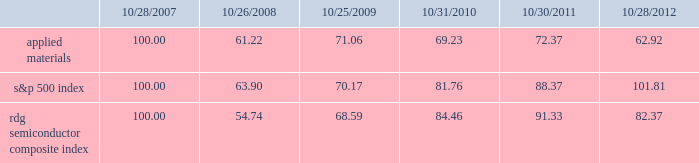Performance graph the performance graph below shows the five-year cumulative total stockholder return on applied common stock during the period from october 28 , 2007 through october 28 , 2012 .
This is compared with the cumulative total return of the standard & poor 2019s 500 stock index and the rdg semiconductor composite index over the same period .
The comparison assumes $ 100 was invested on october 28 , 2007 in applied common stock and in each of the foregoing indices and assumes reinvestment of dividends , if any .
Dollar amounts in the graph are rounded to the nearest whole dollar .
The performance shown in the graph represents past performance and should not be considered an indication of future performance .
Comparison of 5 year cumulative total return* among applied materials , inc. , the s&p 500 index and the rdg semiconductor composite index * $ 100 invested on 10/28/07 in stock or 10/31/07 in index , including reinvestment of dividends .
Indexes calculated on month-end basis .
Copyright a9 2012 s&p , a division of the mcgraw-hill companies inc .
All rights reserved. .
Dividends during fiscal 2012 , applied 2019s board of directors declared three quarterly cash dividends in the amount of $ 0.09 per share each and one quarterly cash dividend in the amount of $ 0.08 per share .
During fiscal 2011 , applied 2019s board of directors declared three quarterly cash dividends in the amount of $ 0.08 per share each and one quarterly cash dividend in the amount of $ 0.07 per share .
During fiscal 2010 , applied 2019s board of directors declared three quarterly cash dividends in the amount of $ 0.07 per share each and one quarterly cash dividend in the amount of $ 0.06 .
Dividends declared during fiscal 2012 , 2011 and 2010 amounted to $ 438 million , $ 408 million and $ 361 million , respectively .
Applied currently anticipates that it will continue to pay cash dividends on a quarterly basis in the future , although the declaration and amount of any future cash dividends are at the discretion of the board of directors and will depend on applied 2019s financial condition , results of operations , capital requirements , business conditions and other factors , as well as a determination that cash dividends are in the best interests of applied 2019s stockholders .
10/28/07 10/26/08 10/25/09 10/31/10 10/30/11 10/28/12 applied materials , inc .
S&p 500 rdg semiconductor composite .
What is the roi of s&p500 if the investment takes place in october 2007 and it is sold in october 2010? 
Computations: ((81.76 - 100) / 100)
Answer: -0.1824. 